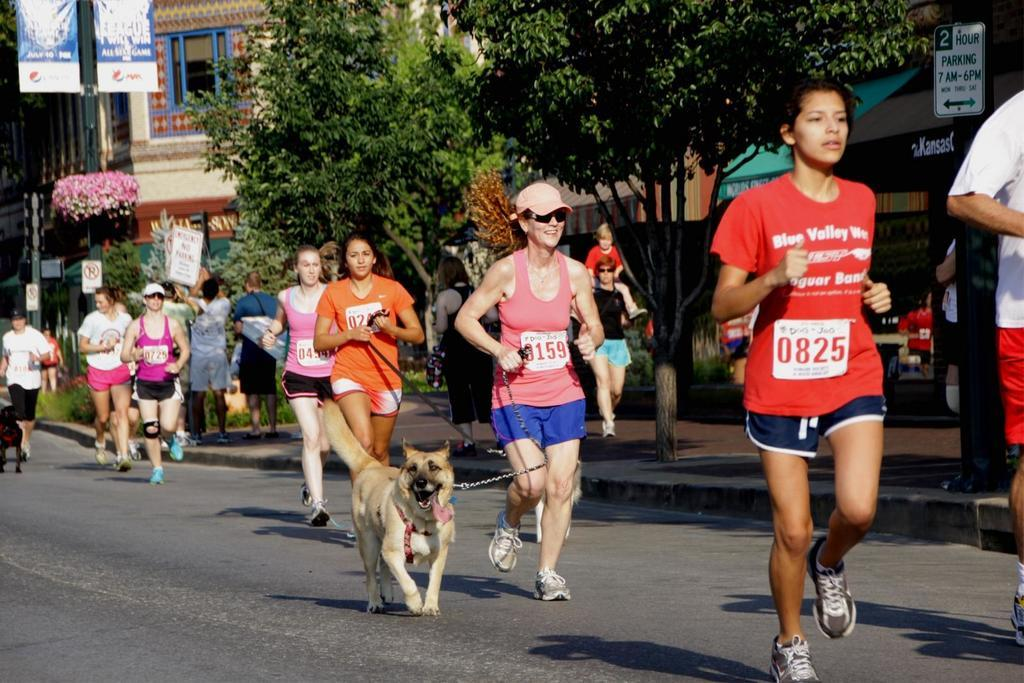What event is taking place in the image? The image depicts a marathon. What are the people in the image doing? There are people running in the marathon. Can you describe any specific detail about one of the runners? A lady among the runners is holding a dog's chain. What type of natural elements can be seen in the image? Trees and flowers are visible in the image. What type of lamp can be seen in the image? There is no lamp present in the image. How many mice are running alongside the people in the marathon? There are no mice running alongside the people in the marathon; only humans are participating in the event. 